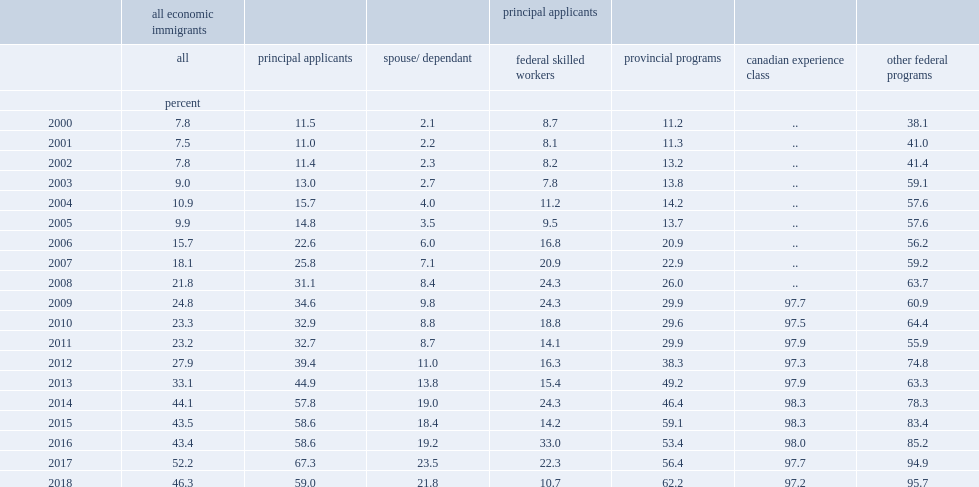In 2000, there was little difference between the fswp and provincial programs in the share of selected immigrants with pre-immigration canadian earnings, how many percent for provincial programs? 11.2. In 2000, there was little difference between the fswp and provincial programs in the share of selected immigrants with pre-immigration canadian earnings, how many percent for federal skilled workers? 8.7. By 2018, how many percent of economic principal applicants had worked in canada before landing? 59.0. By 2018, how many percent of the spouses and dependents had worked in canada before landing? 21.8. 